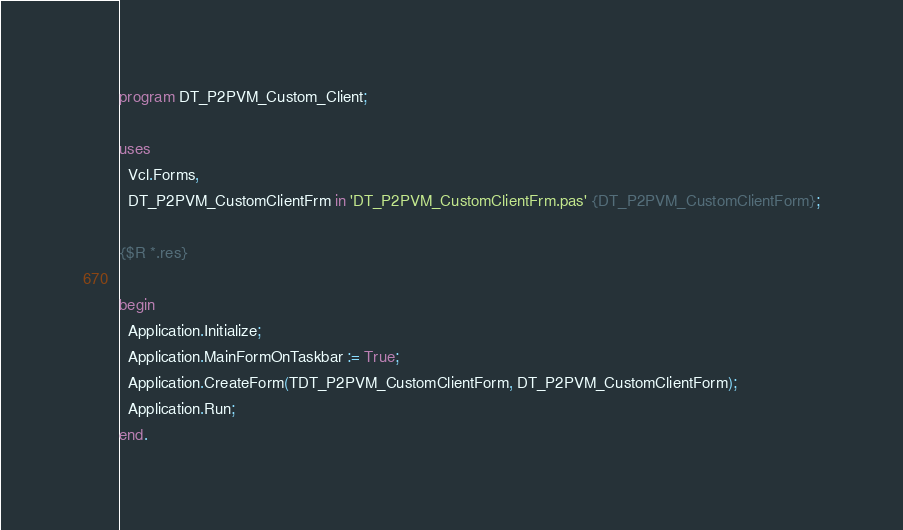Convert code to text. <code><loc_0><loc_0><loc_500><loc_500><_Pascal_>program DT_P2PVM_Custom_Client;

uses
  Vcl.Forms,
  DT_P2PVM_CustomClientFrm in 'DT_P2PVM_CustomClientFrm.pas' {DT_P2PVM_CustomClientForm};

{$R *.res}

begin
  Application.Initialize;
  Application.MainFormOnTaskbar := True;
  Application.CreateForm(TDT_P2PVM_CustomClientForm, DT_P2PVM_CustomClientForm);
  Application.Run;
end.
</code> 